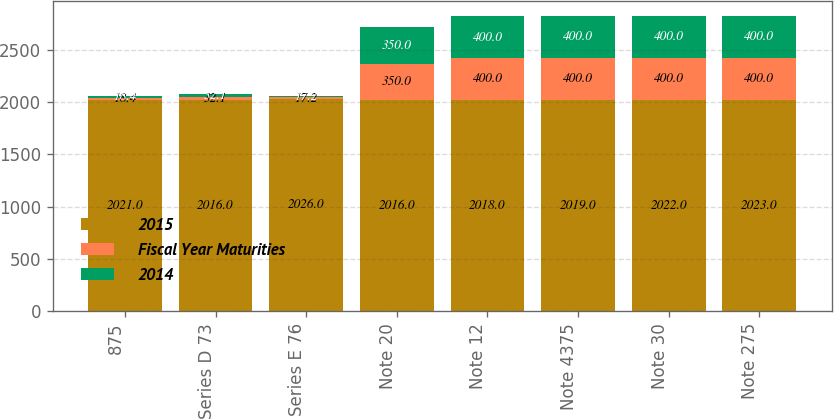<chart> <loc_0><loc_0><loc_500><loc_500><stacked_bar_chart><ecel><fcel>875<fcel>Series D 73<fcel>Series E 76<fcel>Note 20<fcel>Note 12<fcel>Note 4375<fcel>Note 30<fcel>Note 275<nl><fcel>2015<fcel>2021<fcel>2016<fcel>2026<fcel>2016<fcel>2018<fcel>2019<fcel>2022<fcel>2023<nl><fcel>Fiscal Year Maturities<fcel>18.4<fcel>32.1<fcel>17.2<fcel>350<fcel>400<fcel>400<fcel>400<fcel>400<nl><fcel>2014<fcel>18.4<fcel>32.1<fcel>17.2<fcel>350<fcel>400<fcel>400<fcel>400<fcel>400<nl></chart> 